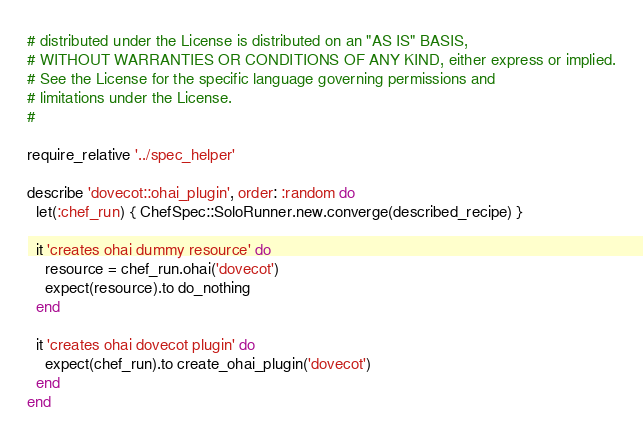<code> <loc_0><loc_0><loc_500><loc_500><_Ruby_># distributed under the License is distributed on an "AS IS" BASIS,
# WITHOUT WARRANTIES OR CONDITIONS OF ANY KIND, either express or implied.
# See the License for the specific language governing permissions and
# limitations under the License.
#

require_relative '../spec_helper'

describe 'dovecot::ohai_plugin', order: :random do
  let(:chef_run) { ChefSpec::SoloRunner.new.converge(described_recipe) }

  it 'creates ohai dummy resource' do
    resource = chef_run.ohai('dovecot')
    expect(resource).to do_nothing
  end

  it 'creates ohai dovecot plugin' do
    expect(chef_run).to create_ohai_plugin('dovecot')
  end
end
</code> 